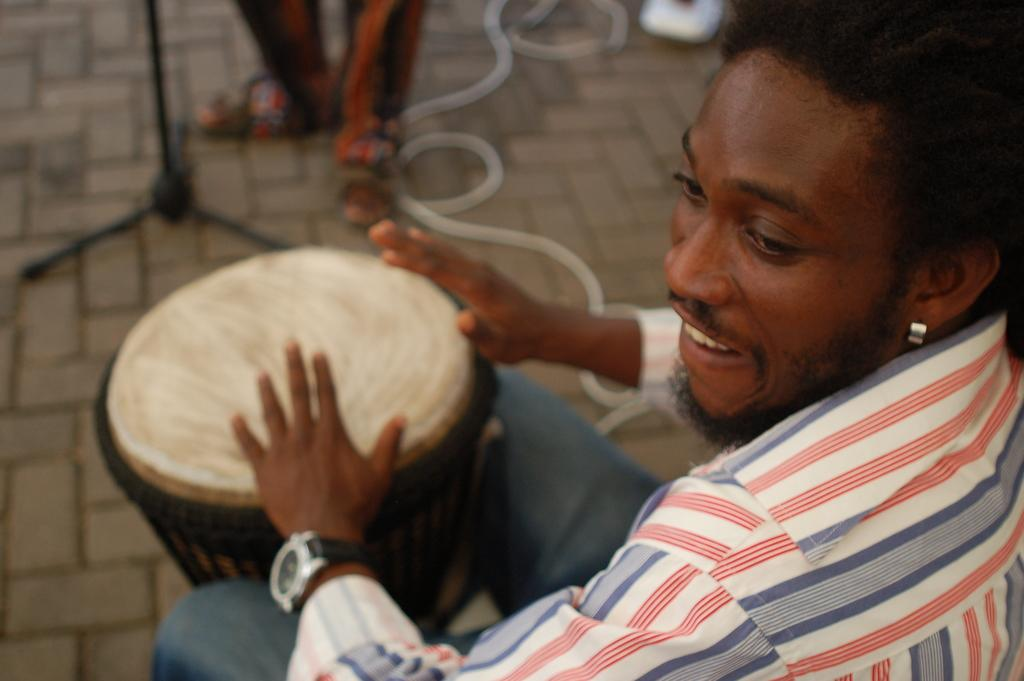What is the main subject of the image? The main subject of the image is a man. What is the man doing in the image? The man is playing a musical instrument in the image. What type of honey is the man using to play the musical instrument in the image? There is no honey present in the image, and the man is not using any honey to play the musical instrument. 